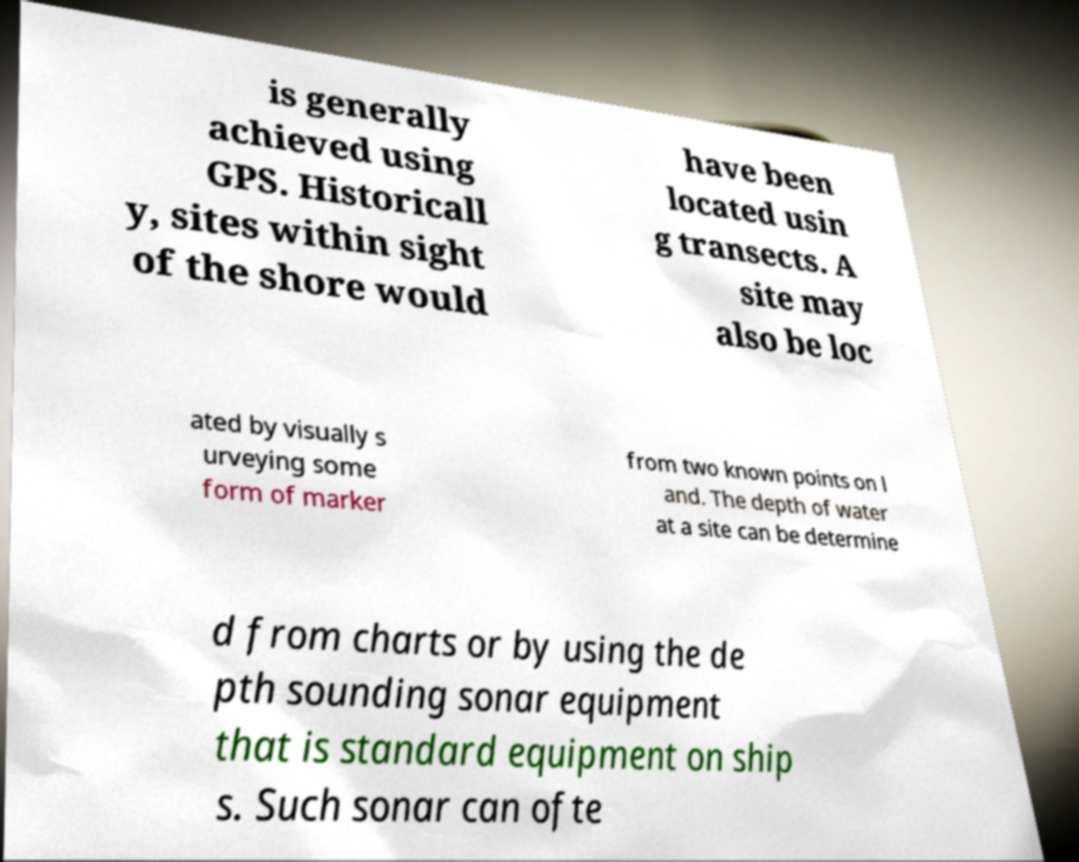Please identify and transcribe the text found in this image. is generally achieved using GPS. Historicall y, sites within sight of the shore would have been located usin g transects. A site may also be loc ated by visually s urveying some form of marker from two known points on l and. The depth of water at a site can be determine d from charts or by using the de pth sounding sonar equipment that is standard equipment on ship s. Such sonar can ofte 